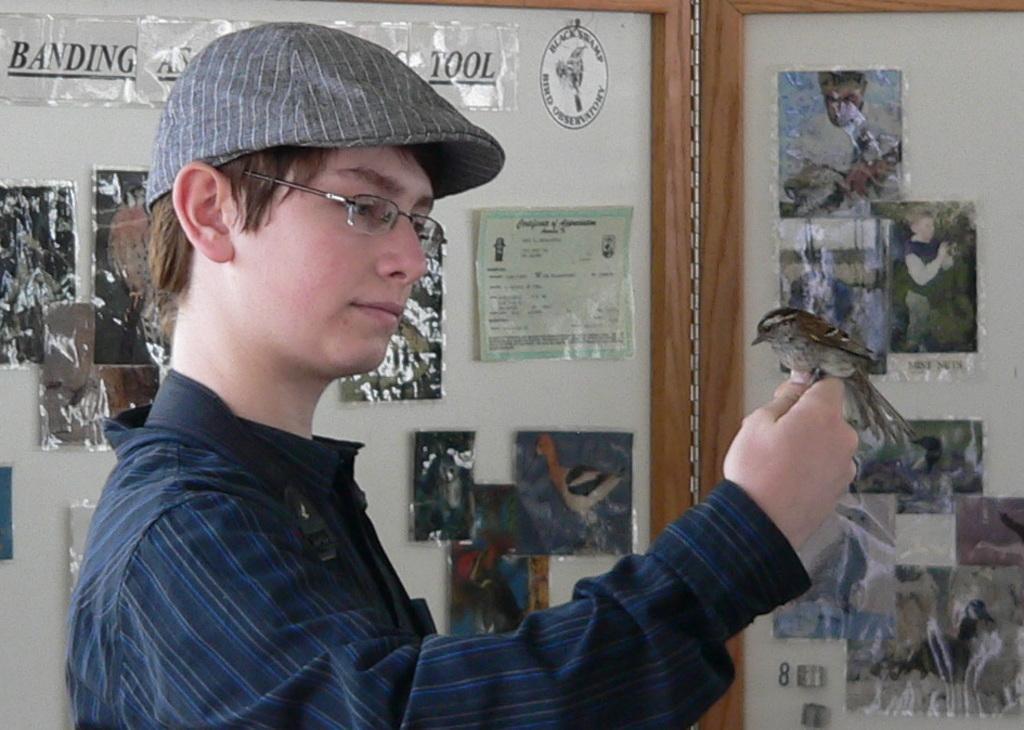In one or two sentences, can you explain what this image depicts? In this picture there is a man who is wearing cap, spectacle and shirt. He is holding a bird. In the back I can see many posts on the board. On the right I can see many photos which are attached on the board. 